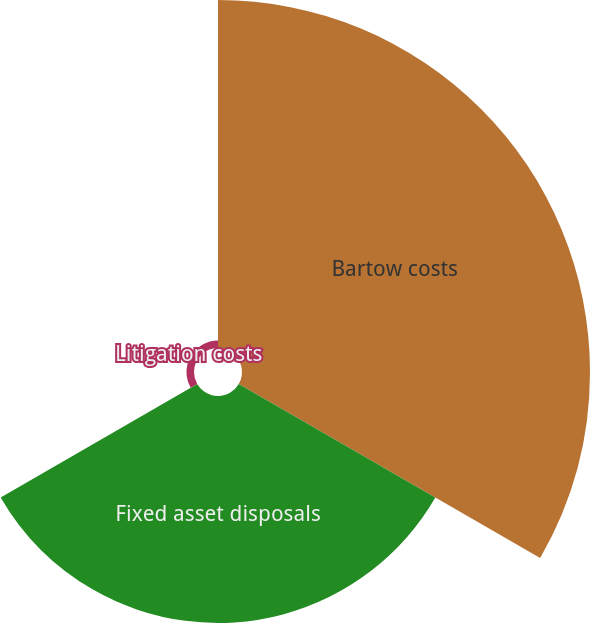Convert chart to OTSL. <chart><loc_0><loc_0><loc_500><loc_500><pie_chart><fcel>Bartow costs<fcel>Fixed asset disposals<fcel>Litigation costs<nl><fcel>59.74%<fcel>38.96%<fcel>1.3%<nl></chart> 